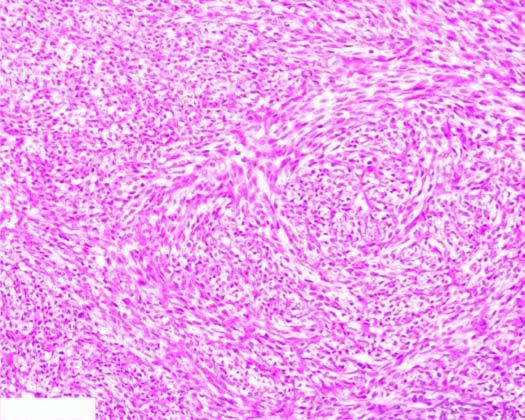re tumour cells resembling epithelioid cells with pleomorphic nuclei and prominent nucleoli arranged in storiform or cartwheel pattern?
Answer the question using a single word or phrase. No 